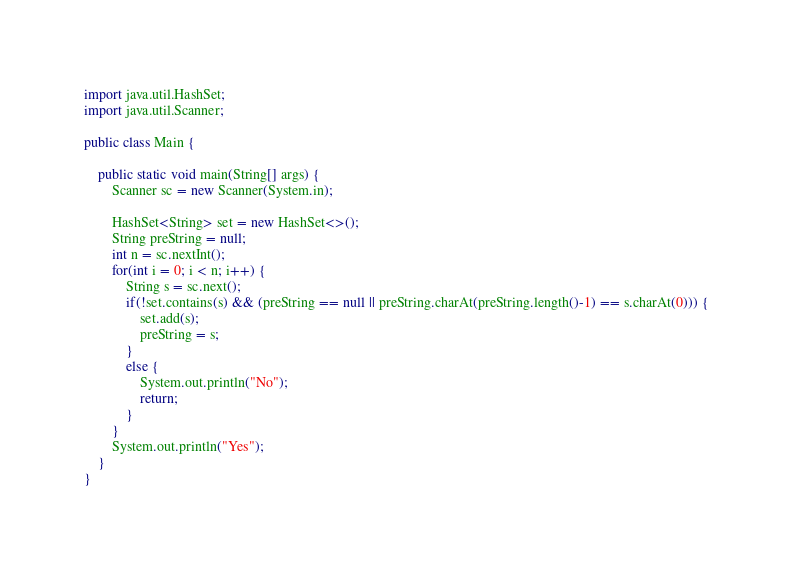Convert code to text. <code><loc_0><loc_0><loc_500><loc_500><_Java_>import java.util.HashSet;
import java.util.Scanner;

public class Main {

    public static void main(String[] args) {
        Scanner sc = new Scanner(System.in);

        HashSet<String> set = new HashSet<>();
        String preString = null;
        int n = sc.nextInt();
        for(int i = 0; i < n; i++) {
            String s = sc.next();
            if(!set.contains(s) && (preString == null || preString.charAt(preString.length()-1) == s.charAt(0))) {
                set.add(s);
                preString = s;
            }
            else {
                System.out.println("No");
                return;
            }
        }
        System.out.println("Yes");
    }
}
</code> 